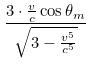<formula> <loc_0><loc_0><loc_500><loc_500>\frac { 3 \cdot \frac { v } { c } \cos \theta _ { m } } { \sqrt { 3 - \frac { v ^ { 5 } } { c ^ { 5 } } } }</formula> 